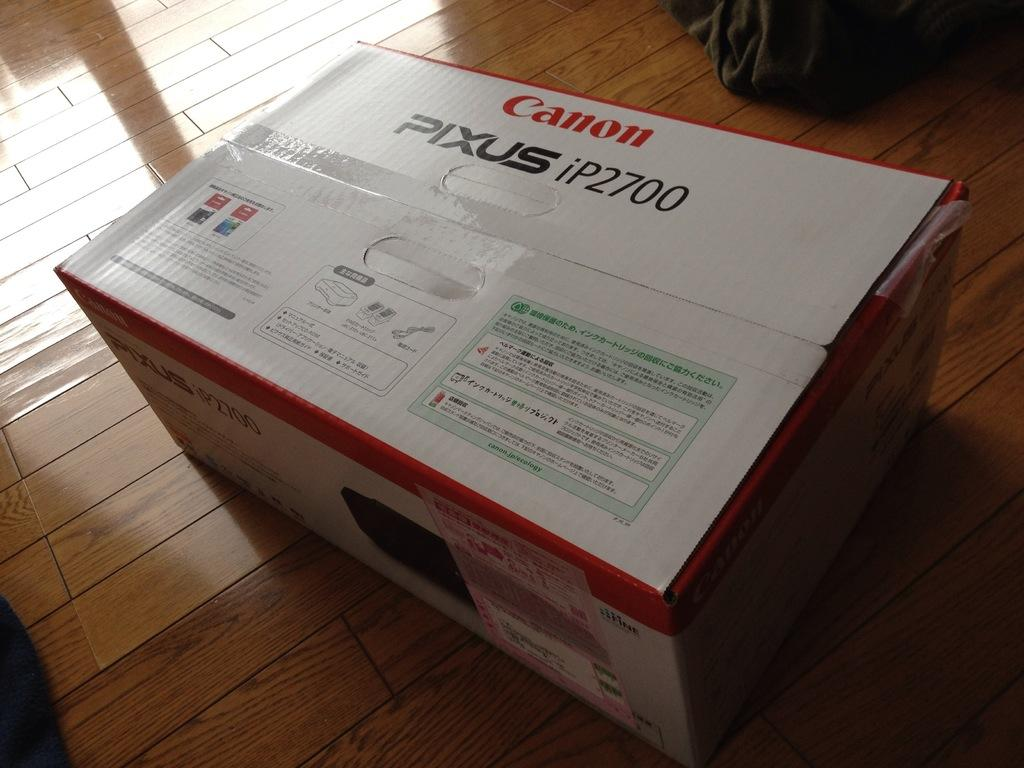Provide a one-sentence caption for the provided image. a box on the floor that is labeled as 'canon pixus ip2700'. 